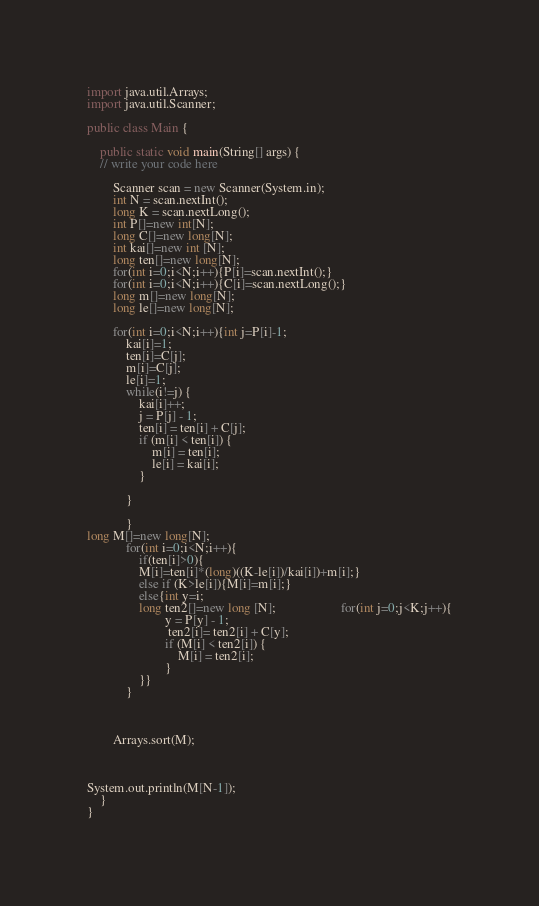Convert code to text. <code><loc_0><loc_0><loc_500><loc_500><_Java_>import java.util.Arrays;
import java.util.Scanner;

public class Main {

    public static void main(String[] args) {
	// write your code here

        Scanner scan = new Scanner(System.in);
        int N = scan.nextInt();
        long K = scan.nextLong();
        int P[]=new int[N];
        long C[]=new long[N];
        int kai[]=new int [N];
        long ten[]=new long[N];
        for(int i=0;i<N;i++){P[i]=scan.nextInt();}
        for(int i=0;i<N;i++){C[i]=scan.nextLong();}
        long m[]=new long[N];
        long le[]=new long[N];

        for(int i=0;i<N;i++){int j=P[i]-1;
            kai[i]=1;
            ten[i]=C[j];
            m[i]=C[j];
            le[i]=1;
            while(i!=j) {
                kai[i]++;
                j = P[j] - 1;
                ten[i] = ten[i] + C[j];
                if (m[i] < ten[i]) {
                    m[i] = ten[i];
                    le[i] = kai[i];
                }

            }

            }
long M[]=new long[N];
            for(int i=0;i<N;i++){
                if(ten[i]>0){
                M[i]=ten[i]*(long)((K-le[i])/kai[i])+m[i];}
                else if (K>le[i]){M[i]=m[i];}
                else{int y=i;
                long ten2[]=new long [N];                    for(int j=0;j<K;j++){
                        y = P[y] - 1;
                         ten2[i]= ten2[i] + C[y];
                        if (M[i] < ten2[i]) {
                            M[i] = ten2[i];
                        }
                }}
            }



        Arrays.sort(M);



System.out.println(M[N-1]);
    }
}
</code> 